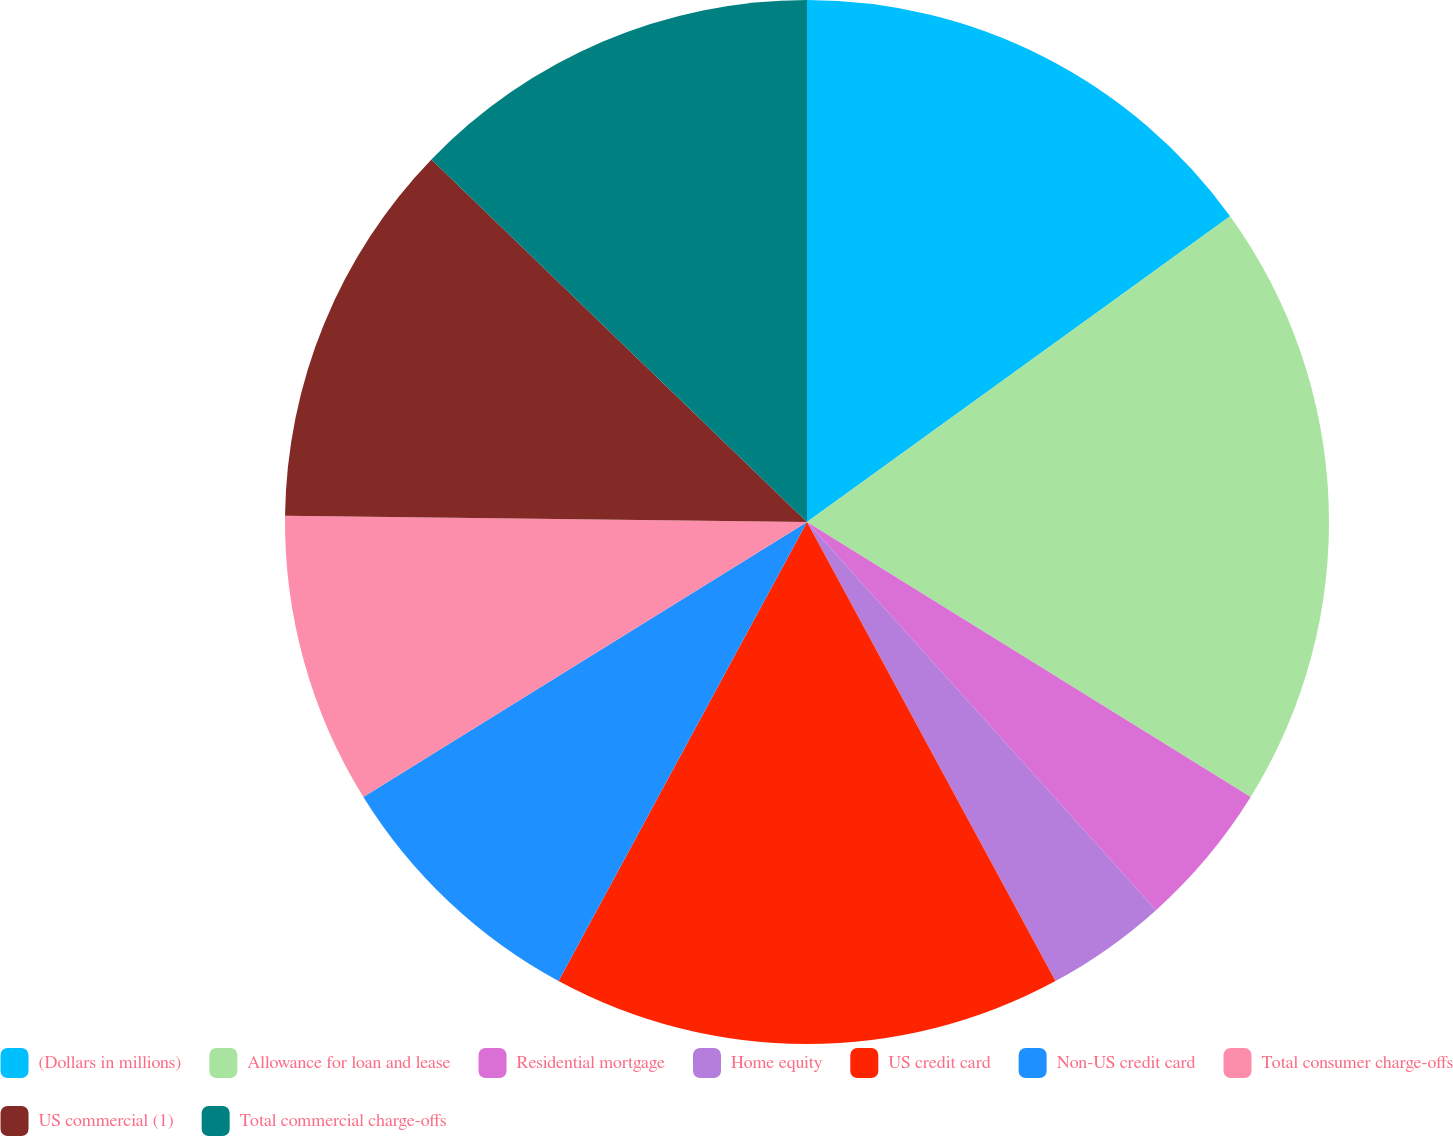Convert chart to OTSL. <chart><loc_0><loc_0><loc_500><loc_500><pie_chart><fcel>(Dollars in millions)<fcel>Allowance for loan and lease<fcel>Residential mortgage<fcel>Home equity<fcel>US credit card<fcel>Non-US credit card<fcel>Total consumer charge-offs<fcel>US commercial (1)<fcel>Total commercial charge-offs<nl><fcel>15.04%<fcel>18.79%<fcel>4.51%<fcel>3.76%<fcel>15.79%<fcel>8.27%<fcel>9.02%<fcel>12.03%<fcel>12.78%<nl></chart> 